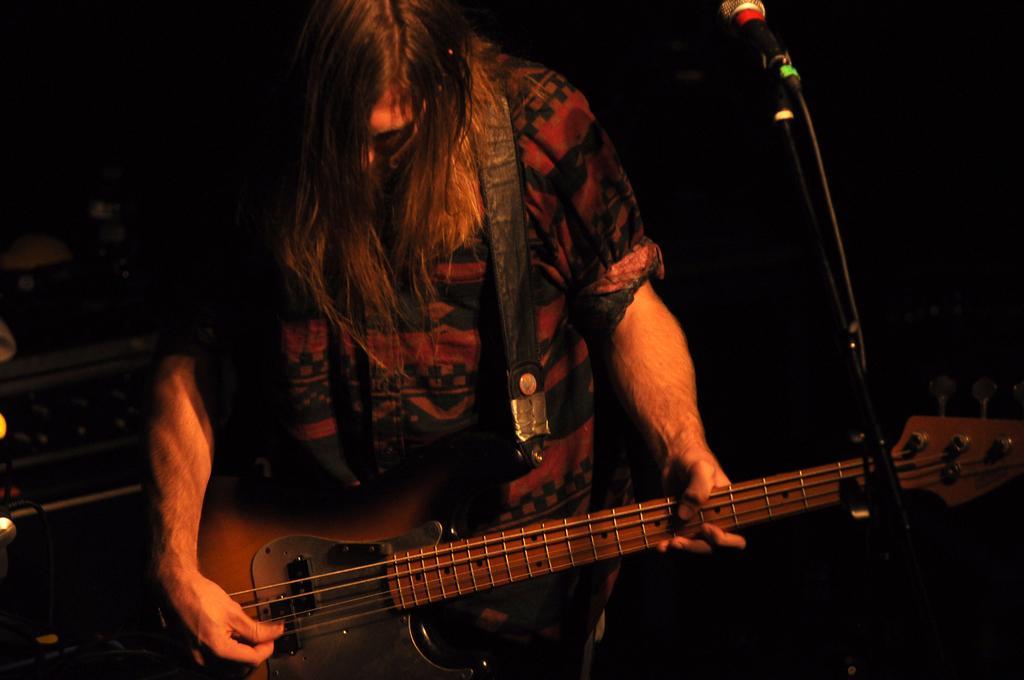Could you give a brief overview of what you see in this image? In this picture there is a man playing a guitar. There is a mic. 